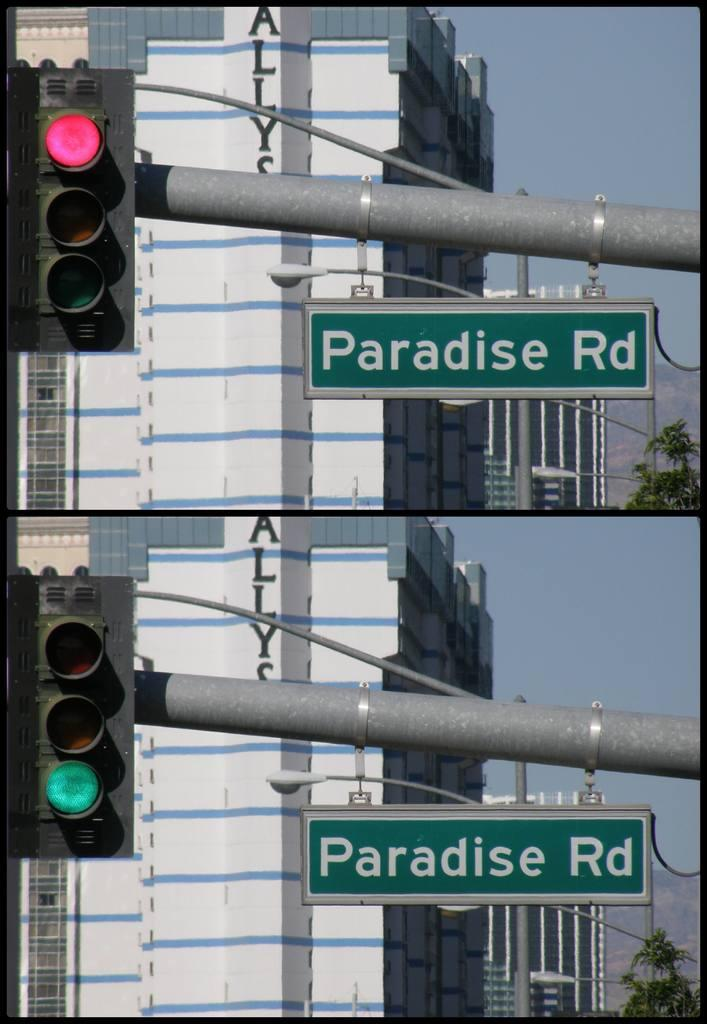<image>
Describe the image concisely. a couple of green road signs that say Paradise Rd 